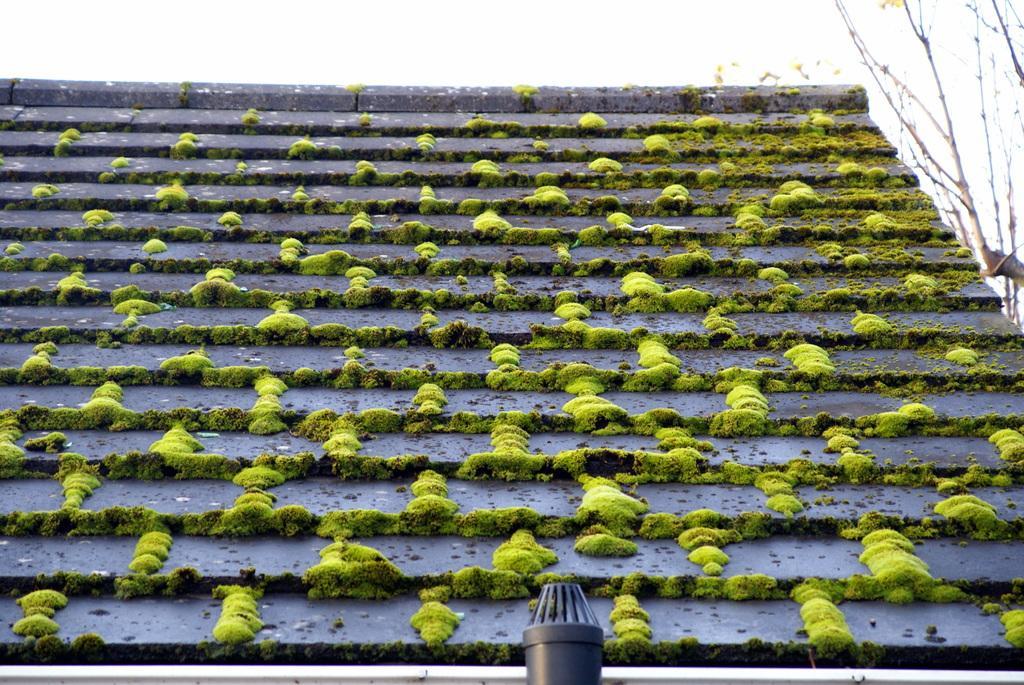Please provide a concise description of this image. In the picture I can see the roof on which we can see algae which is in green color. Here we can see the pipe. On the right side of the image I can see dry trees and the sky in the background. 